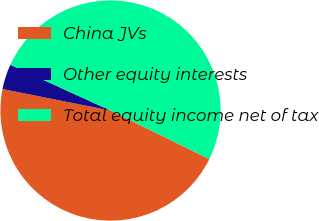Convert chart. <chart><loc_0><loc_0><loc_500><loc_500><pie_chart><fcel>China JVs<fcel>Other equity interests<fcel>Total equity income net of tax<nl><fcel>45.86%<fcel>3.69%<fcel>50.45%<nl></chart> 